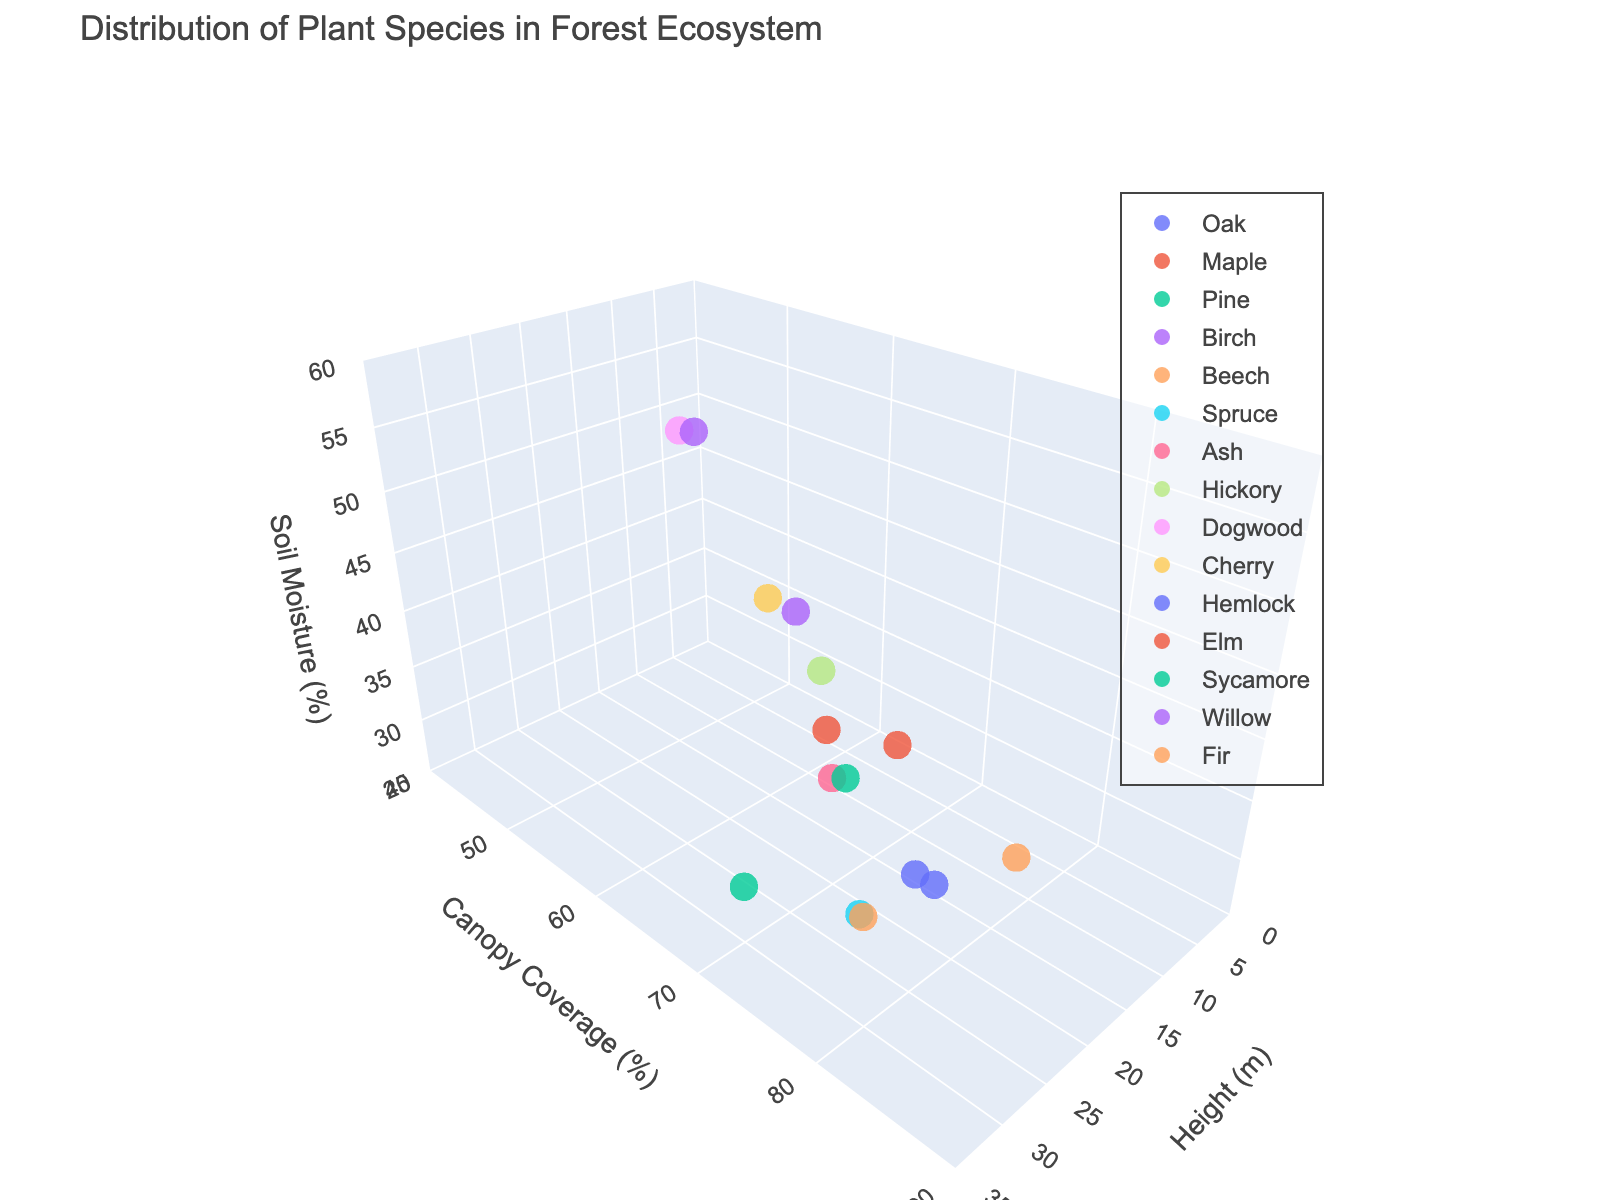What's the title of the plot? The title is usually placed at the top of the plot. By reading the plot's title, we can understand the subject being visualized.
Answer: Distribution of Plant Species in Forest Ecosystem What are the dimensions represented on the axes? In a 3D plot, we typically have three axes for our dimensions. The x-axis, y-axis, and z-axis titles describe what each dimension represents.
Answer: Height (m), Canopy Coverage (%), Soil Moisture (%) Which plant species has the highest height? By observing the x-axis, which represents height in meters, we can identify the highest value and see which plant species marker corresponds to it.
Answer: Pine What is the soil moisture percentage for Birch? To answer this, we locate Birch on the plot and then note the soil moisture value corresponding to its marker position on the z-axis.
Answer: 45% Which species has the lowest canopy coverage? Look at the y-axis values that represent canopy coverage percentages and identify the species marker corresponding to the smallest value.
Answer: Dogwood What is the average height of Oak and Maple combined? First, observe the height values on the x-axis for Oak and Maple (25m and 20m). Then, calculate the average of these heights (25 + 20) / 2.
Answer: 22.5 m Which species have canopy coverage greater than 75%? By examining the y-axis for values greater than 75% and noting the corresponding species markers, we can list the species meeting this criterion.
Answer: Oak, Beech, Hemlock, Fir Which species has the closest soil moisture percentage to Maple? Find Maple's soil moisture on the z-axis (40%) and then identify the species with a soil moisture value nearest to 40%.
Answer: Sycamore Which species are most similar in height and canopy coverage? Identify species markers that are close to each other on both the x-axis (height) and y-axis (canopy coverage), indicating similarities in both dimensions.
Answer: Beech and Ash How does the camera view affect the perception of data points? The position and angle of the camera in a 3D plot can change how data points appear in relation to one another, potentially affecting clarity and depth perception. Understanding the importance of this can help in interpreting data accurately.
Answer: Changes the perspective 